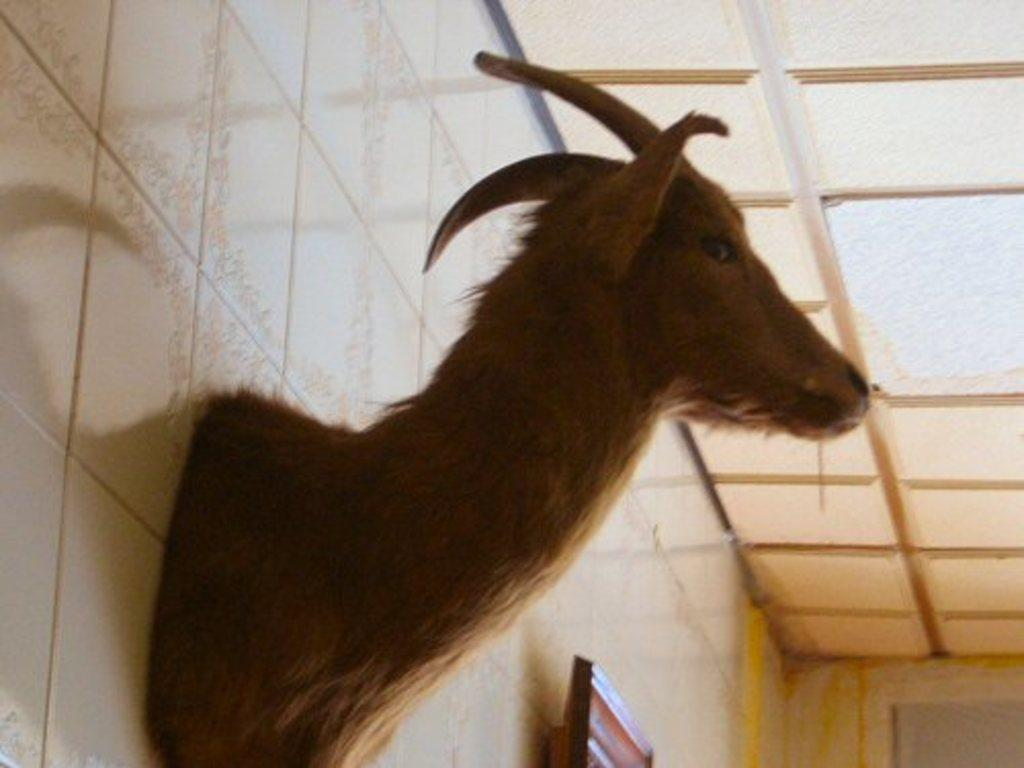What type of animal is depicted as a statue in the image? There is a statue of a deer on the wall in the image. What other object can be seen on the wall in the image? There appears to be a television on the wall at the bottom of the image. Can you see a snail crawling on the wall next to the television in the image? There is no snail present in the image. 